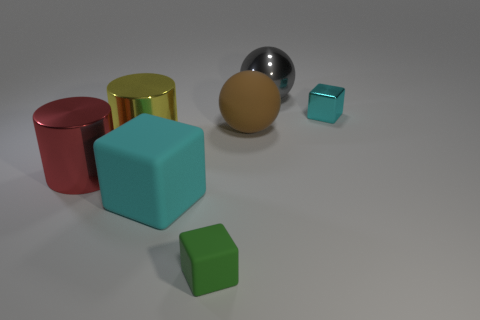Subtract all green blocks. How many blocks are left? 2 Subtract all cyan matte blocks. How many blocks are left? 2 Subtract all brown blocks. How many gray balls are left? 1 Add 6 matte balls. How many matte balls exist? 7 Add 1 cyan rubber things. How many objects exist? 8 Subtract 0 red blocks. How many objects are left? 7 Subtract all blocks. How many objects are left? 4 Subtract all purple spheres. Subtract all yellow cylinders. How many spheres are left? 2 Subtract all cyan metallic things. Subtract all cylinders. How many objects are left? 4 Add 7 large brown spheres. How many large brown spheres are left? 8 